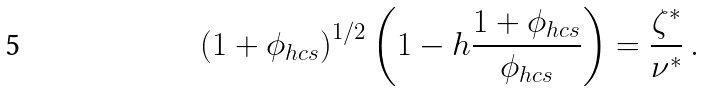<formula> <loc_0><loc_0><loc_500><loc_500>\left ( 1 + \phi _ { h c s } \right ) ^ { 1 / 2 } \left ( 1 - h \frac { 1 + \phi _ { h c s } } { \phi _ { h c s } } \right ) = \frac { \zeta ^ { \ast } } { \nu ^ { \ast } } \, .</formula> 